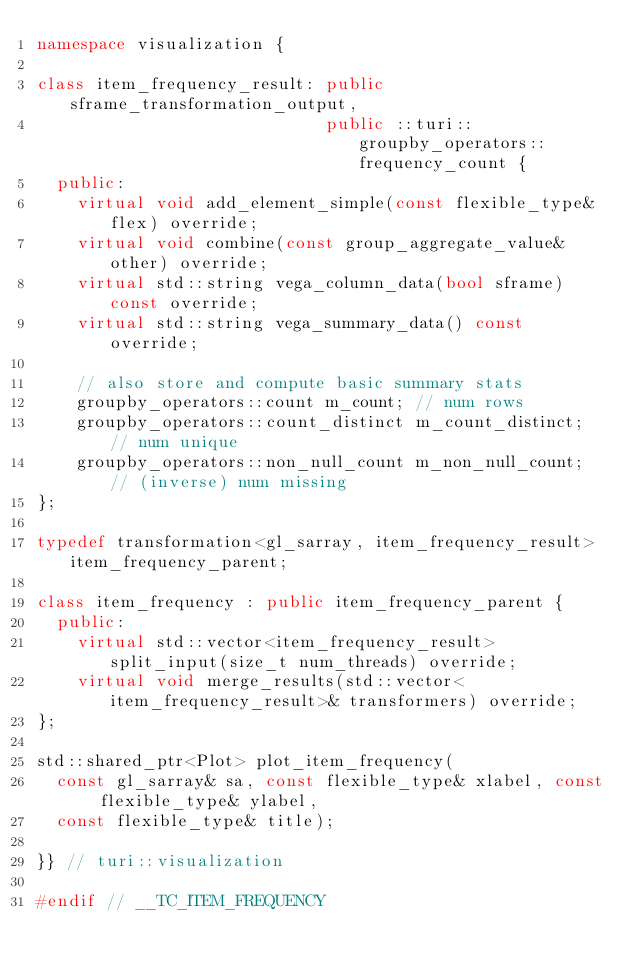Convert code to text. <code><loc_0><loc_0><loc_500><loc_500><_C++_>namespace visualization {

class item_frequency_result: public sframe_transformation_output,
                             public ::turi::groupby_operators::frequency_count {
  public:
    virtual void add_element_simple(const flexible_type& flex) override;
    virtual void combine(const group_aggregate_value& other) override;
    virtual std::string vega_column_data(bool sframe) const override;
    virtual std::string vega_summary_data() const override;

    // also store and compute basic summary stats
    groupby_operators::count m_count; // num rows
    groupby_operators::count_distinct m_count_distinct; // num unique
    groupby_operators::non_null_count m_non_null_count; // (inverse) num missing
};

typedef transformation<gl_sarray, item_frequency_result> item_frequency_parent;

class item_frequency : public item_frequency_parent {
  public:
    virtual std::vector<item_frequency_result> split_input(size_t num_threads) override;
    virtual void merge_results(std::vector<item_frequency_result>& transformers) override;
};

std::shared_ptr<Plot> plot_item_frequency(
  const gl_sarray& sa, const flexible_type& xlabel, const flexible_type& ylabel, 
  const flexible_type& title);

}} // turi::visualization

#endif // __TC_ITEM_FREQUENCY
</code> 